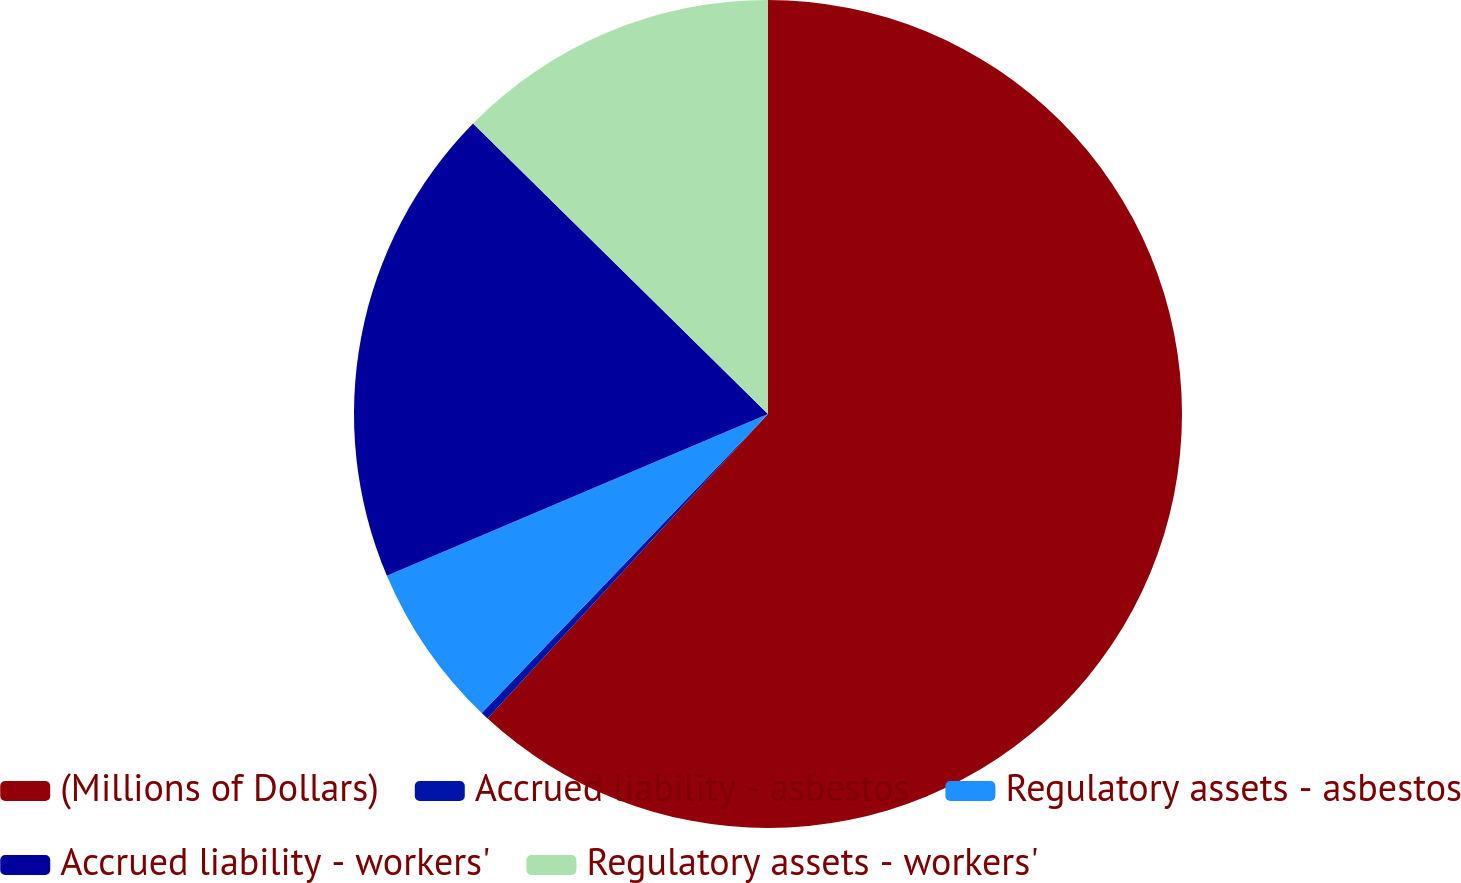<chart> <loc_0><loc_0><loc_500><loc_500><pie_chart><fcel>(Millions of Dollars)<fcel>Accrued liability - asbestos<fcel>Regulatory assets - asbestos<fcel>Accrued liability - workers'<fcel>Regulatory assets - workers'<nl><fcel>61.85%<fcel>0.31%<fcel>6.46%<fcel>18.77%<fcel>12.62%<nl></chart> 